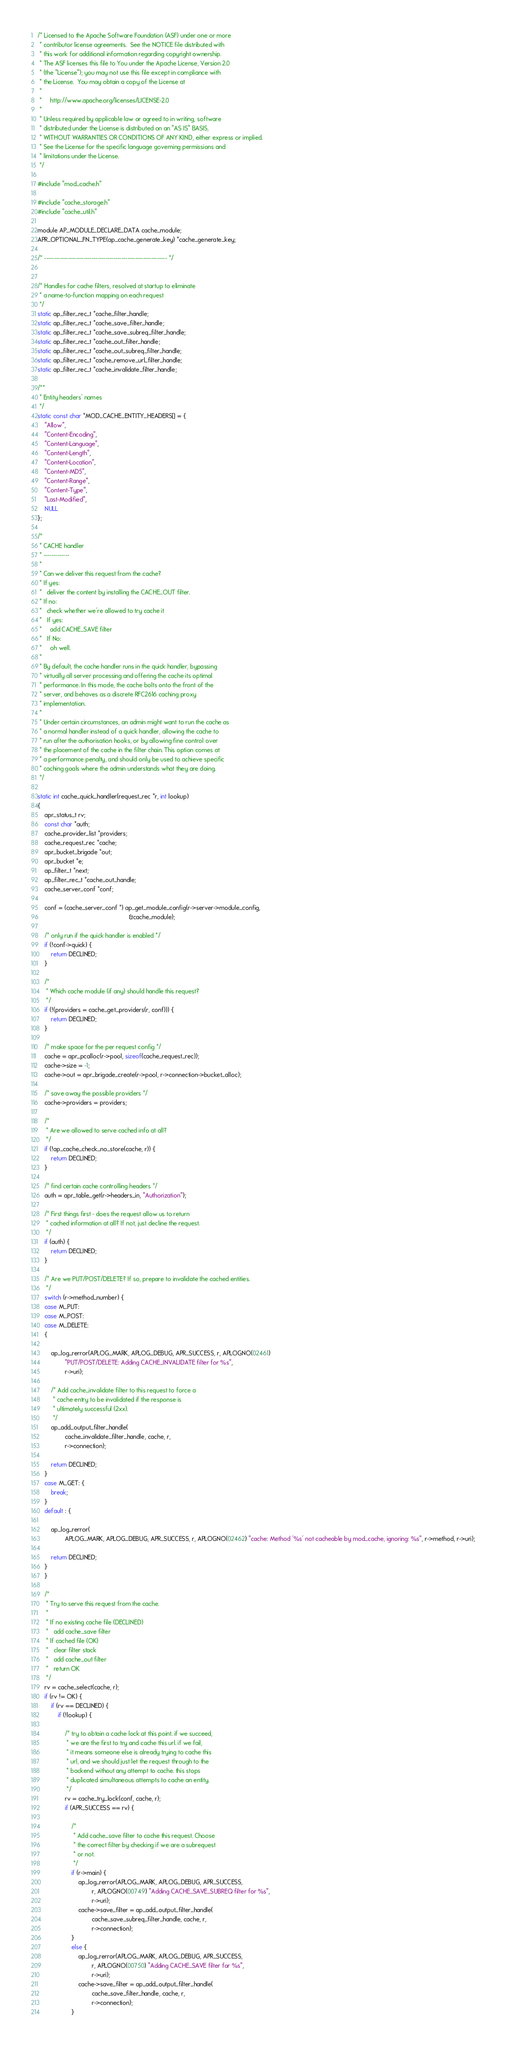<code> <loc_0><loc_0><loc_500><loc_500><_C_>/* Licensed to the Apache Software Foundation (ASF) under one or more
 * contributor license agreements.  See the NOTICE file distributed with
 * this work for additional information regarding copyright ownership.
 * The ASF licenses this file to You under the Apache License, Version 2.0
 * (the "License"); you may not use this file except in compliance with
 * the License.  You may obtain a copy of the License at
 *
 *     http://www.apache.org/licenses/LICENSE-2.0
 *
 * Unless required by applicable law or agreed to in writing, software
 * distributed under the License is distributed on an "AS IS" BASIS,
 * WITHOUT WARRANTIES OR CONDITIONS OF ANY KIND, either express or implied.
 * See the License for the specific language governing permissions and
 * limitations under the License.
 */

#include "mod_cache.h"

#include "cache_storage.h"
#include "cache_util.h"

module AP_MODULE_DECLARE_DATA cache_module;
APR_OPTIONAL_FN_TYPE(ap_cache_generate_key) *cache_generate_key;

/* -------------------------------------------------------------- */


/* Handles for cache filters, resolved at startup to eliminate
 * a name-to-function mapping on each request
 */
static ap_filter_rec_t *cache_filter_handle;
static ap_filter_rec_t *cache_save_filter_handle;
static ap_filter_rec_t *cache_save_subreq_filter_handle;
static ap_filter_rec_t *cache_out_filter_handle;
static ap_filter_rec_t *cache_out_subreq_filter_handle;
static ap_filter_rec_t *cache_remove_url_filter_handle;
static ap_filter_rec_t *cache_invalidate_filter_handle;

/**
 * Entity headers' names
 */
static const char *MOD_CACHE_ENTITY_HEADERS[] = {
    "Allow",
    "Content-Encoding",
    "Content-Language",
    "Content-Length",
    "Content-Location",
    "Content-MD5",
    "Content-Range",
    "Content-Type",
    "Last-Modified",
    NULL
};

/*
 * CACHE handler
 * -------------
 *
 * Can we deliver this request from the cache?
 * If yes:
 *   deliver the content by installing the CACHE_OUT filter.
 * If no:
 *   check whether we're allowed to try cache it
 *   If yes:
 *     add CACHE_SAVE filter
 *   If No:
 *     oh well.
 *
 * By default, the cache handler runs in the quick handler, bypassing
 * virtually all server processing and offering the cache its optimal
 * performance. In this mode, the cache bolts onto the front of the
 * server, and behaves as a discrete RFC2616 caching proxy
 * implementation.
 *
 * Under certain circumstances, an admin might want to run the cache as
 * a normal handler instead of a quick handler, allowing the cache to
 * run after the authorisation hooks, or by allowing fine control over
 * the placement of the cache in the filter chain. This option comes at
 * a performance penalty, and should only be used to achieve specific
 * caching goals where the admin understands what they are doing.
 */

static int cache_quick_handler(request_rec *r, int lookup)
{
    apr_status_t rv;
    const char *auth;
    cache_provider_list *providers;
    cache_request_rec *cache;
    apr_bucket_brigade *out;
    apr_bucket *e;
    ap_filter_t *next;
    ap_filter_rec_t *cache_out_handle;
    cache_server_conf *conf;

    conf = (cache_server_conf *) ap_get_module_config(r->server->module_config,
                                                      &cache_module);

    /* only run if the quick handler is enabled */
    if (!conf->quick) {
        return DECLINED;
    }

    /*
     * Which cache module (if any) should handle this request?
     */
    if (!(providers = cache_get_providers(r, conf))) {
        return DECLINED;
    }

    /* make space for the per request config */
    cache = apr_pcalloc(r->pool, sizeof(cache_request_rec));
    cache->size = -1;
    cache->out = apr_brigade_create(r->pool, r->connection->bucket_alloc);

    /* save away the possible providers */
    cache->providers = providers;

    /*
     * Are we allowed to serve cached info at all?
     */
    if (!ap_cache_check_no_store(cache, r)) {
        return DECLINED;
    }

    /* find certain cache controlling headers */
    auth = apr_table_get(r->headers_in, "Authorization");

    /* First things first - does the request allow us to return
     * cached information at all? If not, just decline the request.
     */
    if (auth) {
        return DECLINED;
    }

    /* Are we PUT/POST/DELETE? If so, prepare to invalidate the cached entities.
     */
    switch (r->method_number) {
    case M_PUT:
    case M_POST:
    case M_DELETE:
    {

        ap_log_rerror(APLOG_MARK, APLOG_DEBUG, APR_SUCCESS, r, APLOGNO(02461)
                "PUT/POST/DELETE: Adding CACHE_INVALIDATE filter for %s",
                r->uri);

        /* Add cache_invalidate filter to this request to force a
         * cache entry to be invalidated if the response is
         * ultimately successful (2xx).
         */
        ap_add_output_filter_handle(
                cache_invalidate_filter_handle, cache, r,
                r->connection);

        return DECLINED;
    }
    case M_GET: {
        break;
    }
    default : {

        ap_log_rerror(
                APLOG_MARK, APLOG_DEBUG, APR_SUCCESS, r, APLOGNO(02462) "cache: Method '%s' not cacheable by mod_cache, ignoring: %s", r->method, r->uri);

        return DECLINED;
    }
    }

    /*
     * Try to serve this request from the cache.
     *
     * If no existing cache file (DECLINED)
     *   add cache_save filter
     * If cached file (OK)
     *   clear filter stack
     *   add cache_out filter
     *   return OK
     */
    rv = cache_select(cache, r);
    if (rv != OK) {
        if (rv == DECLINED) {
            if (!lookup) {

                /* try to obtain a cache lock at this point. if we succeed,
                 * we are the first to try and cache this url. if we fail,
                 * it means someone else is already trying to cache this
                 * url, and we should just let the request through to the
                 * backend without any attempt to cache. this stops
                 * duplicated simultaneous attempts to cache an entity.
                 */
                rv = cache_try_lock(conf, cache, r);
                if (APR_SUCCESS == rv) {

                    /*
                     * Add cache_save filter to cache this request. Choose
                     * the correct filter by checking if we are a subrequest
                     * or not.
                     */
                    if (r->main) {
                        ap_log_rerror(APLOG_MARK, APLOG_DEBUG, APR_SUCCESS,
                                r, APLOGNO(00749) "Adding CACHE_SAVE_SUBREQ filter for %s",
                                r->uri);
                        cache->save_filter = ap_add_output_filter_handle(
                                cache_save_subreq_filter_handle, cache, r,
                                r->connection);
                    }
                    else {
                        ap_log_rerror(APLOG_MARK, APLOG_DEBUG, APR_SUCCESS,
                                r, APLOGNO(00750) "Adding CACHE_SAVE filter for %s",
                                r->uri);
                        cache->save_filter = ap_add_output_filter_handle(
                                cache_save_filter_handle, cache, r,
                                r->connection);
                    }
</code> 